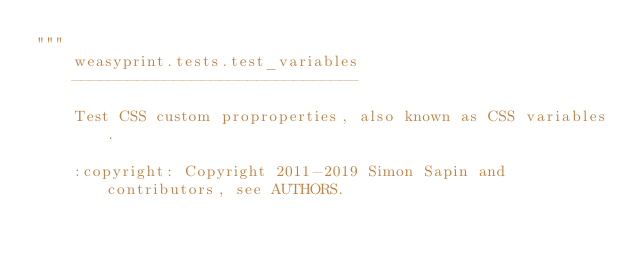<code> <loc_0><loc_0><loc_500><loc_500><_Python_>"""
    weasyprint.tests.test_variables
    -------------------------------

    Test CSS custom proproperties, also known as CSS variables.

    :copyright: Copyright 2011-2019 Simon Sapin and contributors, see AUTHORS.</code> 